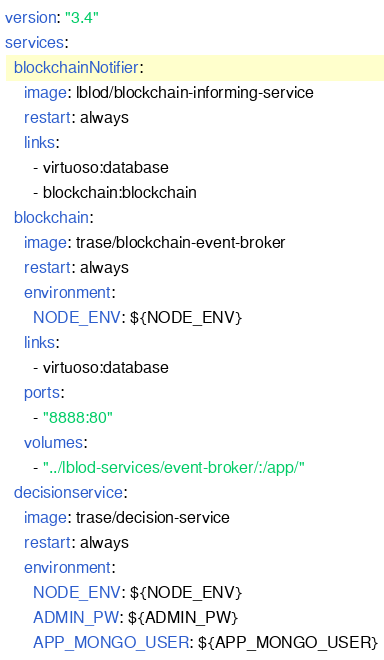<code> <loc_0><loc_0><loc_500><loc_500><_YAML_>version: "3.4"
services:
  blockchainNotifier:
    image: lblod/blockchain-informing-service
    restart: always
    links:
      - virtuoso:database
      - blockchain:blockchain
  blockchain:
    image: trase/blockchain-event-broker
    restart: always
    environment:
      NODE_ENV: ${NODE_ENV}
    links:
      - virtuoso:database
    ports:
      - "8888:80"
    volumes:
      - "../lblod-services/event-broker/:/app/"
  decisionservice:
    image: trase/decision-service
    restart: always
    environment:
      NODE_ENV: ${NODE_ENV}
      ADMIN_PW: ${ADMIN_PW}
      APP_MONGO_USER: ${APP_MONGO_USER}</code> 